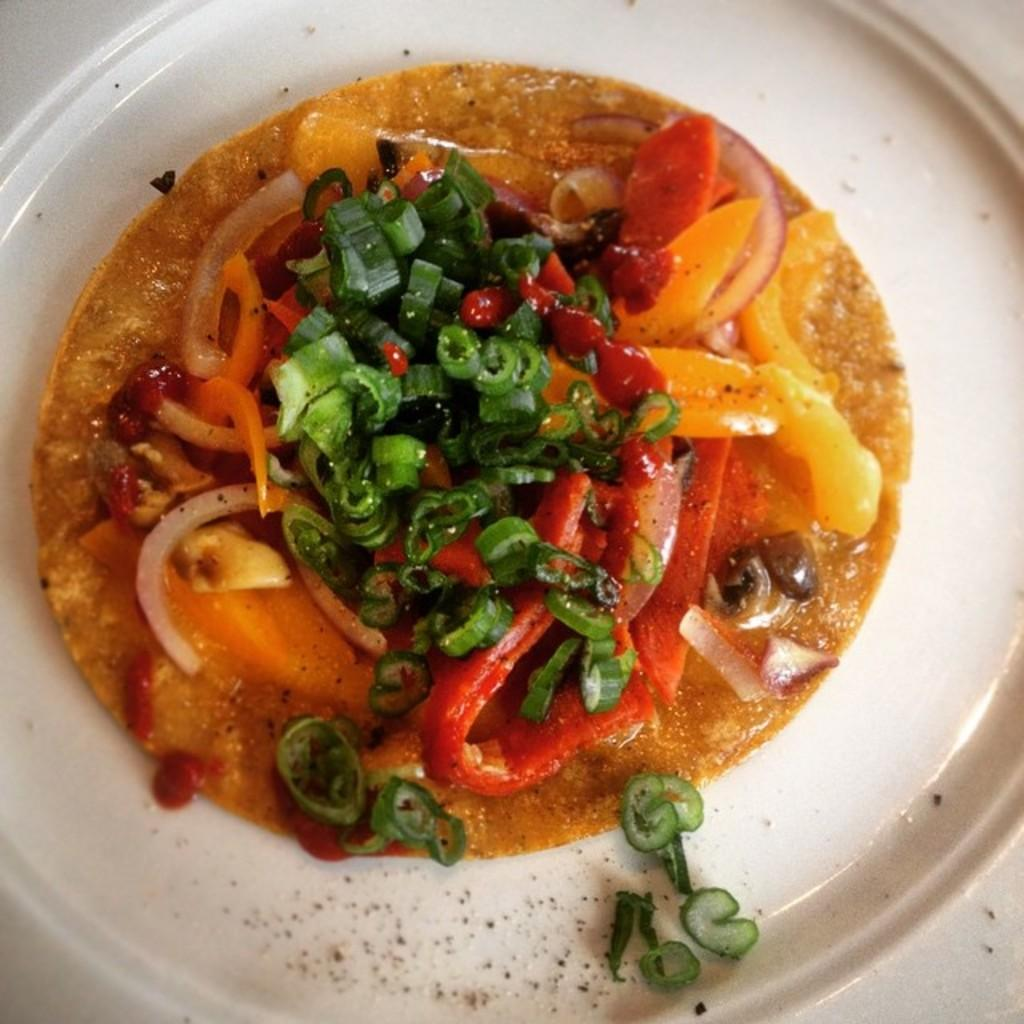What is present in the image? There is a bowl in the image. What is inside the bowl? There is food in the bowl. What type of apparel is being worn by the food in the image? There is no apparel present in the image, as the subject is food in a bowl. 